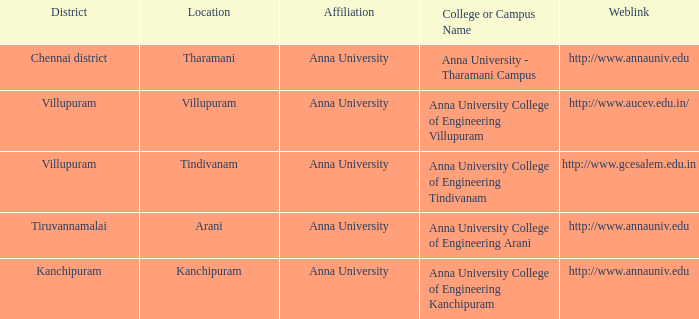Which district is home to a college or campus known as anna university college of engineering kanchipuram? Kanchipuram. 